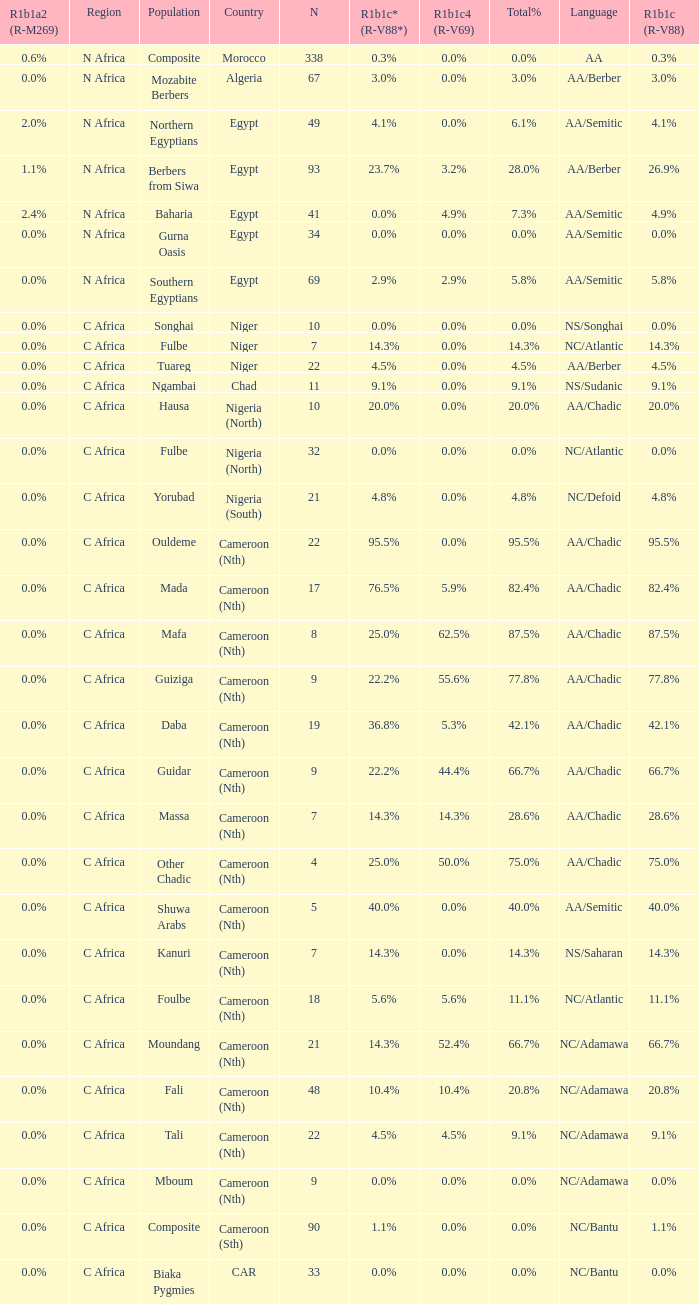I'm looking to parse the entire table for insights. Could you assist me with that? {'header': ['R1b1a2 (R-M269)', 'Region', 'Population', 'Country', 'N', 'R1b1c* (R-V88*)', 'R1b1c4 (R-V69)', 'Total%', 'Language', 'R1b1c (R-V88)'], 'rows': [['0.6%', 'N Africa', 'Composite', 'Morocco', '338', '0.3%', '0.0%', '0.0%', 'AA', '0.3%'], ['0.0%', 'N Africa', 'Mozabite Berbers', 'Algeria', '67', '3.0%', '0.0%', '3.0%', 'AA/Berber', '3.0%'], ['2.0%', 'N Africa', 'Northern Egyptians', 'Egypt', '49', '4.1%', '0.0%', '6.1%', 'AA/Semitic', '4.1%'], ['1.1%', 'N Africa', 'Berbers from Siwa', 'Egypt', '93', '23.7%', '3.2%', '28.0%', 'AA/Berber', '26.9%'], ['2.4%', 'N Africa', 'Baharia', 'Egypt', '41', '0.0%', '4.9%', '7.3%', 'AA/Semitic', '4.9%'], ['0.0%', 'N Africa', 'Gurna Oasis', 'Egypt', '34', '0.0%', '0.0%', '0.0%', 'AA/Semitic', '0.0%'], ['0.0%', 'N Africa', 'Southern Egyptians', 'Egypt', '69', '2.9%', '2.9%', '5.8%', 'AA/Semitic', '5.8%'], ['0.0%', 'C Africa', 'Songhai', 'Niger', '10', '0.0%', '0.0%', '0.0%', 'NS/Songhai', '0.0%'], ['0.0%', 'C Africa', 'Fulbe', 'Niger', '7', '14.3%', '0.0%', '14.3%', 'NC/Atlantic', '14.3%'], ['0.0%', 'C Africa', 'Tuareg', 'Niger', '22', '4.5%', '0.0%', '4.5%', 'AA/Berber', '4.5%'], ['0.0%', 'C Africa', 'Ngambai', 'Chad', '11', '9.1%', '0.0%', '9.1%', 'NS/Sudanic', '9.1%'], ['0.0%', 'C Africa', 'Hausa', 'Nigeria (North)', '10', '20.0%', '0.0%', '20.0%', 'AA/Chadic', '20.0%'], ['0.0%', 'C Africa', 'Fulbe', 'Nigeria (North)', '32', '0.0%', '0.0%', '0.0%', 'NC/Atlantic', '0.0%'], ['0.0%', 'C Africa', 'Yorubad', 'Nigeria (South)', '21', '4.8%', '0.0%', '4.8%', 'NC/Defoid', '4.8%'], ['0.0%', 'C Africa', 'Ouldeme', 'Cameroon (Nth)', '22', '95.5%', '0.0%', '95.5%', 'AA/Chadic', '95.5%'], ['0.0%', 'C Africa', 'Mada', 'Cameroon (Nth)', '17', '76.5%', '5.9%', '82.4%', 'AA/Chadic', '82.4%'], ['0.0%', 'C Africa', 'Mafa', 'Cameroon (Nth)', '8', '25.0%', '62.5%', '87.5%', 'AA/Chadic', '87.5%'], ['0.0%', 'C Africa', 'Guiziga', 'Cameroon (Nth)', '9', '22.2%', '55.6%', '77.8%', 'AA/Chadic', '77.8%'], ['0.0%', 'C Africa', 'Daba', 'Cameroon (Nth)', '19', '36.8%', '5.3%', '42.1%', 'AA/Chadic', '42.1%'], ['0.0%', 'C Africa', 'Guidar', 'Cameroon (Nth)', '9', '22.2%', '44.4%', '66.7%', 'AA/Chadic', '66.7%'], ['0.0%', 'C Africa', 'Massa', 'Cameroon (Nth)', '7', '14.3%', '14.3%', '28.6%', 'AA/Chadic', '28.6%'], ['0.0%', 'C Africa', 'Other Chadic', 'Cameroon (Nth)', '4', '25.0%', '50.0%', '75.0%', 'AA/Chadic', '75.0%'], ['0.0%', 'C Africa', 'Shuwa Arabs', 'Cameroon (Nth)', '5', '40.0%', '0.0%', '40.0%', 'AA/Semitic', '40.0%'], ['0.0%', 'C Africa', 'Kanuri', 'Cameroon (Nth)', '7', '14.3%', '0.0%', '14.3%', 'NS/Saharan', '14.3%'], ['0.0%', 'C Africa', 'Foulbe', 'Cameroon (Nth)', '18', '5.6%', '5.6%', '11.1%', 'NC/Atlantic', '11.1%'], ['0.0%', 'C Africa', 'Moundang', 'Cameroon (Nth)', '21', '14.3%', '52.4%', '66.7%', 'NC/Adamawa', '66.7%'], ['0.0%', 'C Africa', 'Fali', 'Cameroon (Nth)', '48', '10.4%', '10.4%', '20.8%', 'NC/Adamawa', '20.8%'], ['0.0%', 'C Africa', 'Tali', 'Cameroon (Nth)', '22', '4.5%', '4.5%', '9.1%', 'NC/Adamawa', '9.1%'], ['0.0%', 'C Africa', 'Mboum', 'Cameroon (Nth)', '9', '0.0%', '0.0%', '0.0%', 'NC/Adamawa', '0.0%'], ['0.0%', 'C Africa', 'Composite', 'Cameroon (Sth)', '90', '1.1%', '0.0%', '0.0%', 'NC/Bantu', '1.1%'], ['0.0%', 'C Africa', 'Biaka Pygmies', 'CAR', '33', '0.0%', '0.0%', '0.0%', 'NC/Bantu', '0.0%']]} 6% r1b1a2 (r-m269)? 1.0. 